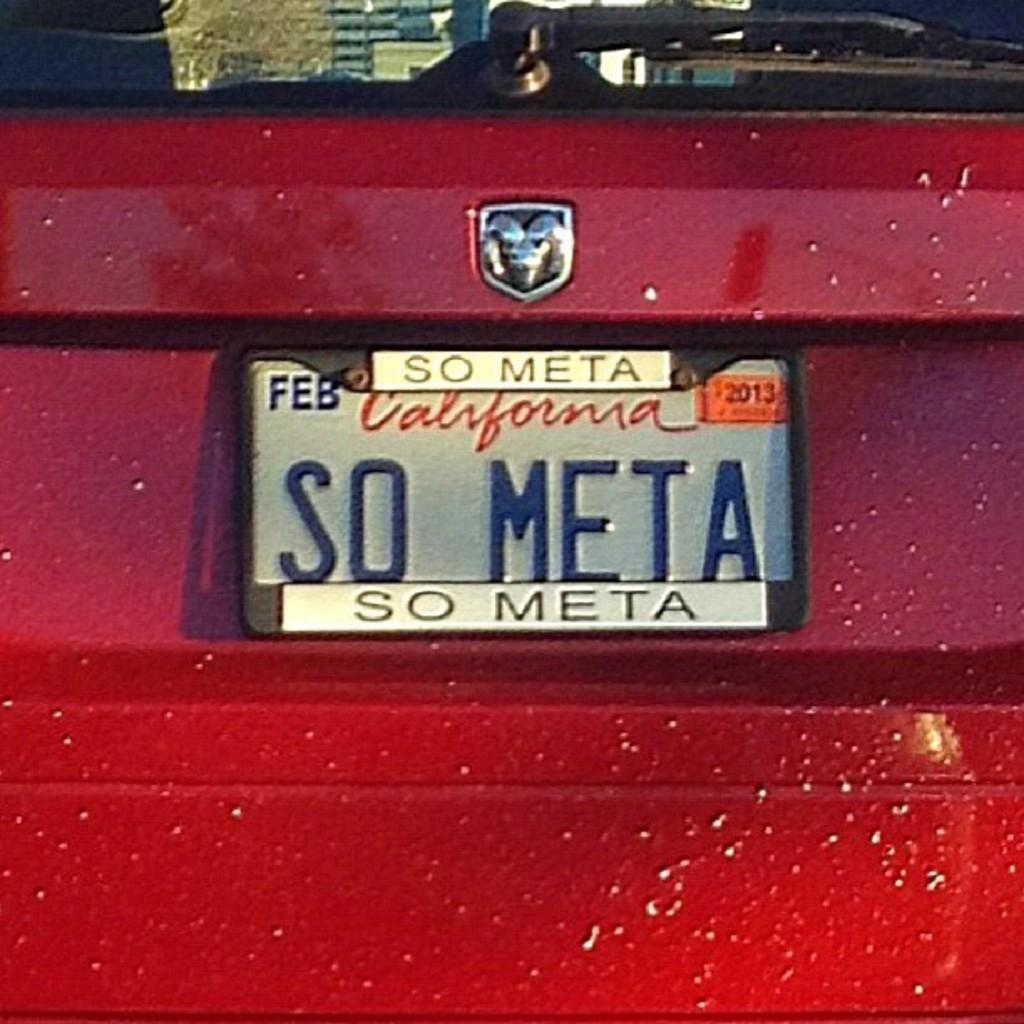<image>
Provide a brief description of the given image. A red dodge car has the license plate So Meta. 